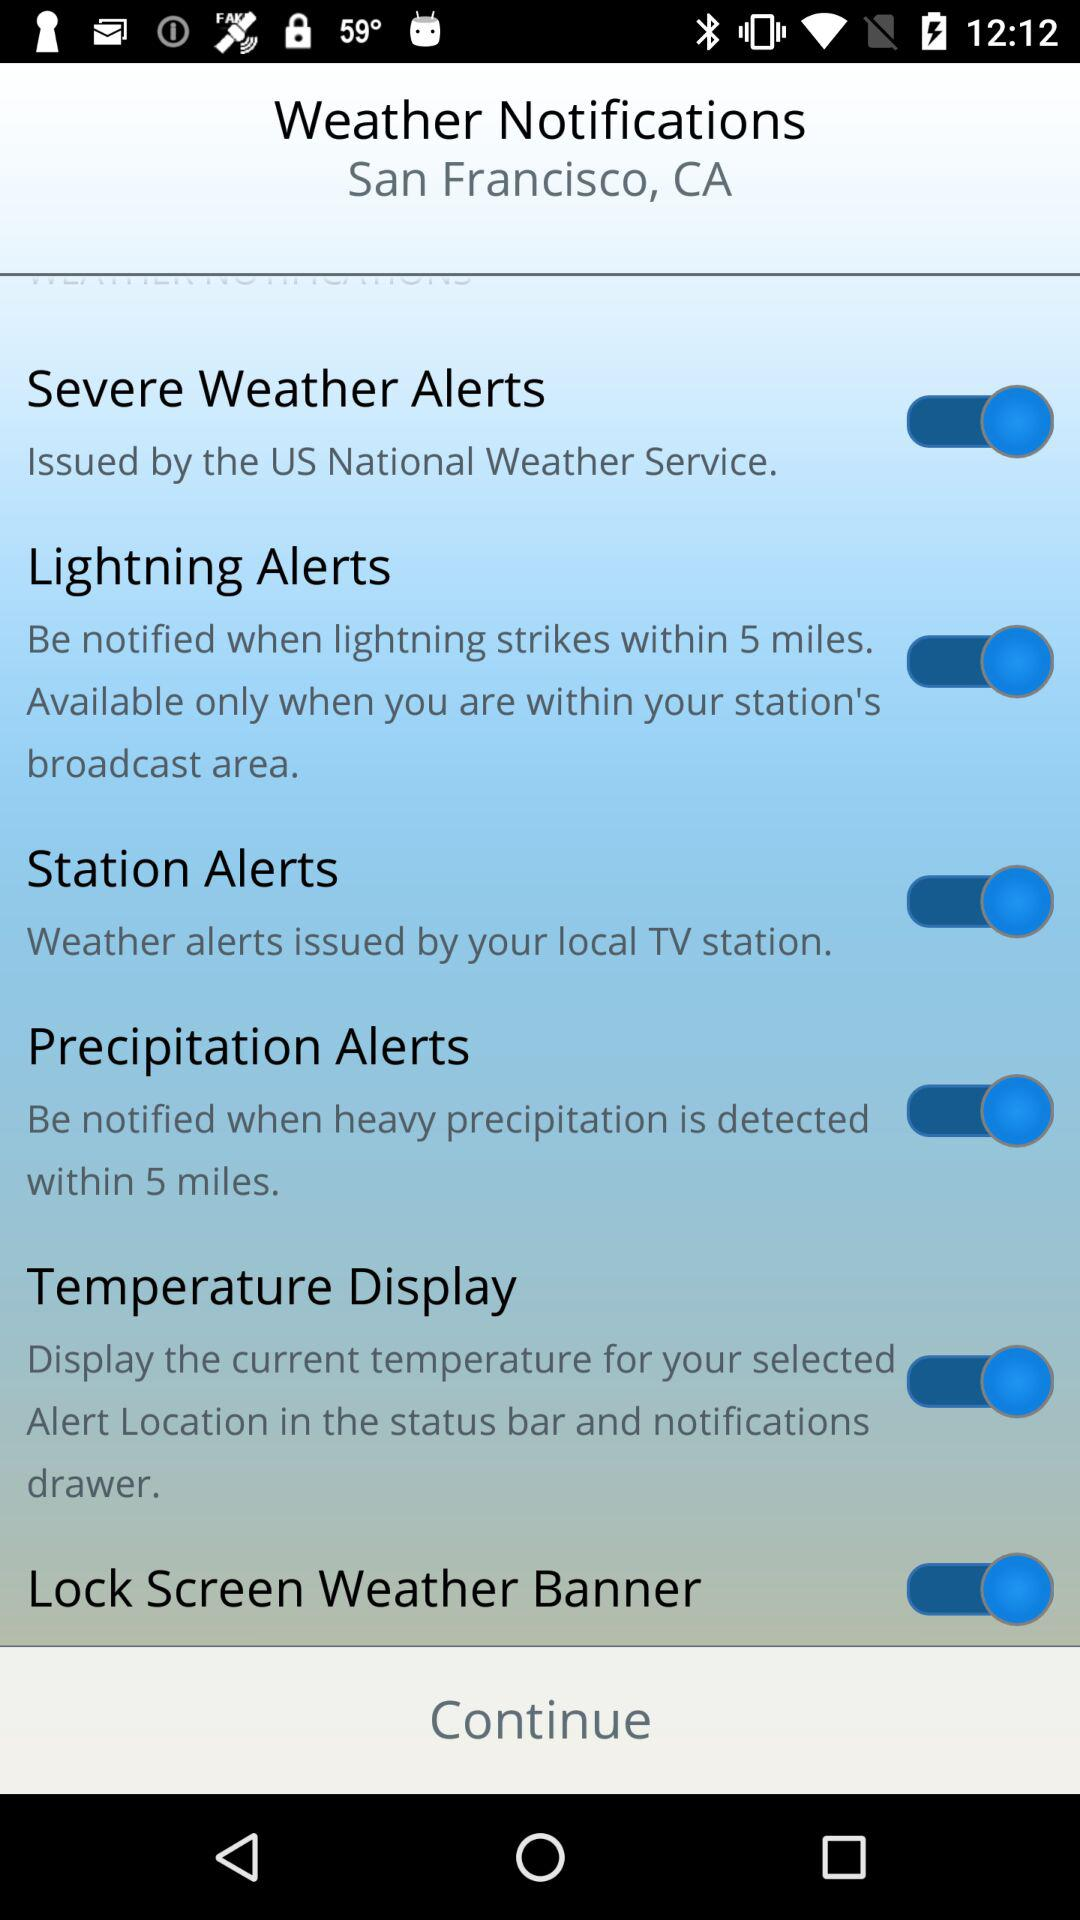What is the status of "Station Alerts"? The status is "on". 